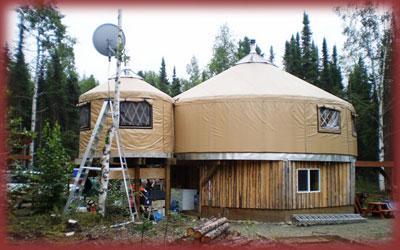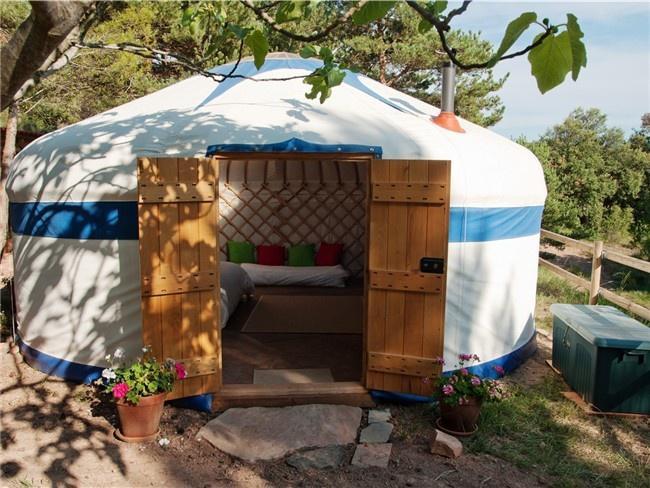The first image is the image on the left, the second image is the image on the right. For the images displayed, is the sentence "In one image, a round house has a round wrap-around porch." factually correct? Answer yes or no. No. The first image is the image on the left, the second image is the image on the right. Given the left and right images, does the statement "An image shows a round house on stilts surrounded by a railing and deck." hold true? Answer yes or no. No. 